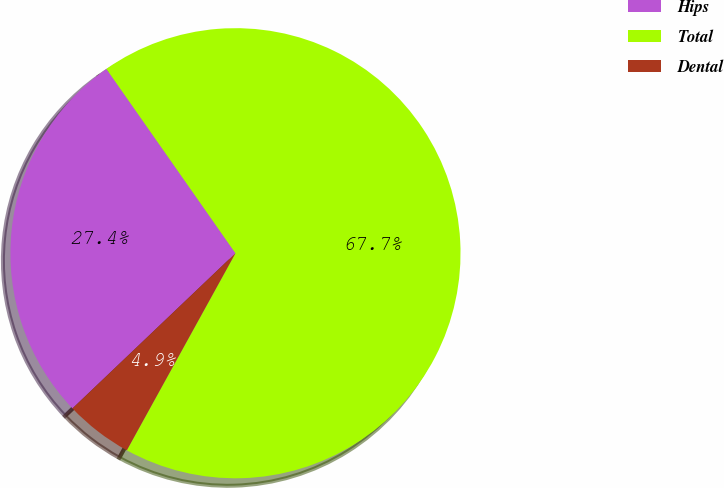<chart> <loc_0><loc_0><loc_500><loc_500><pie_chart><fcel>Hips<fcel>Total<fcel>Dental<nl><fcel>27.39%<fcel>67.74%<fcel>4.87%<nl></chart> 